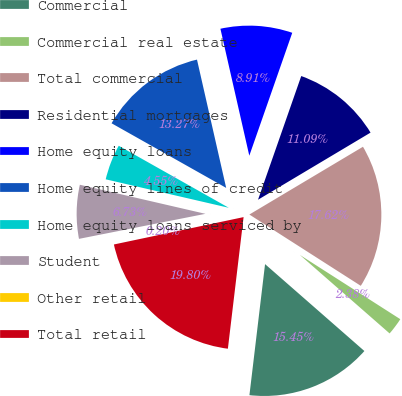Convert chart. <chart><loc_0><loc_0><loc_500><loc_500><pie_chart><fcel>Commercial<fcel>Commercial real estate<fcel>Total commercial<fcel>Residential mortgages<fcel>Home equity loans<fcel>Home equity lines of credit<fcel>Home equity loans serviced by<fcel>Student<fcel>Other retail<fcel>Total retail<nl><fcel>15.45%<fcel>2.38%<fcel>17.62%<fcel>11.09%<fcel>8.91%<fcel>13.27%<fcel>4.55%<fcel>6.73%<fcel>0.2%<fcel>19.8%<nl></chart> 